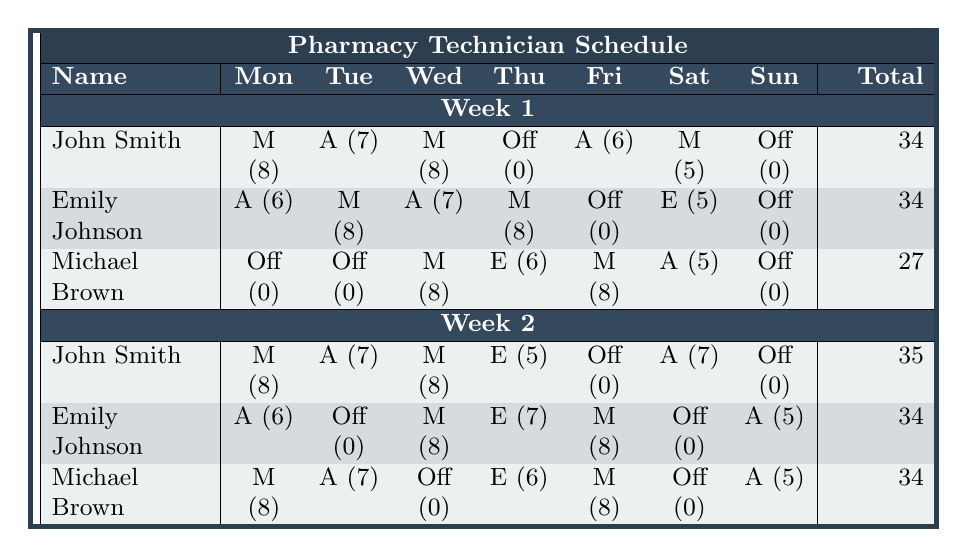What is the total number of hours worked by John Smith in Week 1? Referring to the table, John Smith's total hours in Week 1 is listed as 34.
Answer: 34 How many afternoons did Emily Johnson work in Week 2? Looking at Emily Johnson's schedule for Week 2, she worked in the Afternoon on Monday (6 hours) and on Sunday (5 hours), so that is a total of 2 afternoons.
Answer: 2 Who had the least total hours in Week 1? By examining the total hours column for Week 1, Michael Brown has the least total hours at 27.
Answer: Michael Brown What is the average number of hours worked by the staff in Week 2? The total hours for Week 2 are: John Smith (35), Emily Johnson (34), and Michael Brown (34). Adding these gives 35 + 34 + 34 = 103. Dividing by the number of staff (3) gives 103/3 = approximately 34.33.
Answer: 34.33 Did any technician work on both days of the weekend in Week 1? Looking at the weekend shifts (Saturday and Sunday), both John Smith and Emily Johnson worked on Saturday, but both had Sundays off. Therefore, none worked both days.
Answer: No What was the highest number of hours worked in a single week by a Pharmacy Technician? Examining the total hours, John Smith worked 35 hours in Week 2, which is the maximum.
Answer: 35 In Week 1, how many total hours did the technicians work on their days off? In Week 1, only John Smith, Emily Johnson, and Michael Brown had days off on Thursday and Sunday, which contributed 0 hours, so the total is 0.
Answer: 0 Which technician worked the maximum hours on Tuesday across both weeks? Comparing Tuesdays, John Smith worked 7 hours in both weeks, Emily Johnson worked 8 hours in Week 1 and was off in Week 2, while Michael Brown worked 0 hours in both weeks. Therefore, the maximum hours worked on Tuesday is 8 by Emily Johnson in Week 1.
Answer: Emily Johnson How many total hours did Michael Brown work across both weeks? Michael Brown worked 27 hours in Week 1 and 34 hours in Week 2. Summing these gives 27 + 34 = 61 hours.
Answer: 61 Which shift had the most hours worked by the pharmacy technicians on Wednesday in Week 2? In Week 2, John Smith worked 8 hours (Morning), Emily Johnson worked 8 hours (Morning), and Michael Brown worked 0 hours (Off). The highest worked shift is Morning at 8 hours.
Answer: Morning (8 hours) 